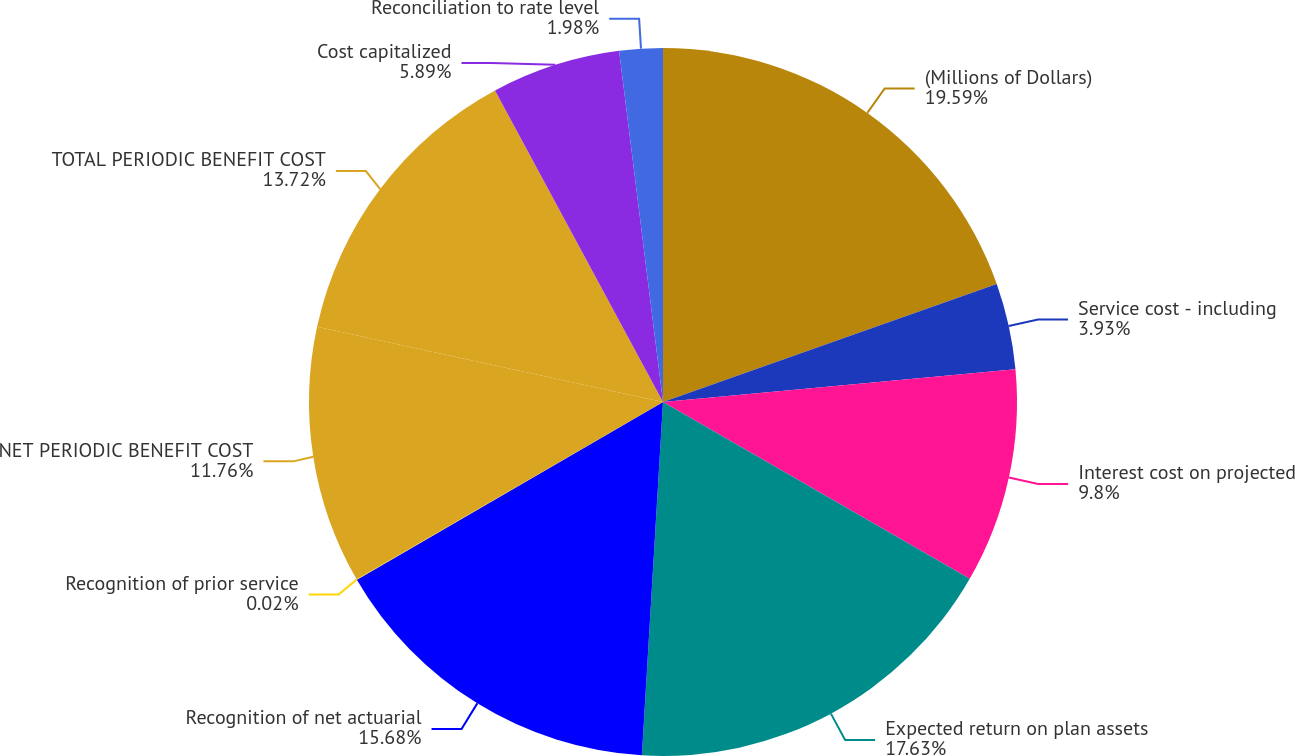Convert chart to OTSL. <chart><loc_0><loc_0><loc_500><loc_500><pie_chart><fcel>(Millions of Dollars)<fcel>Service cost - including<fcel>Interest cost on projected<fcel>Expected return on plan assets<fcel>Recognition of net actuarial<fcel>Recognition of prior service<fcel>NET PERIODIC BENEFIT COST<fcel>TOTAL PERIODIC BENEFIT COST<fcel>Cost capitalized<fcel>Reconciliation to rate level<nl><fcel>19.59%<fcel>3.93%<fcel>9.8%<fcel>17.63%<fcel>15.68%<fcel>0.02%<fcel>11.76%<fcel>13.72%<fcel>5.89%<fcel>1.98%<nl></chart> 